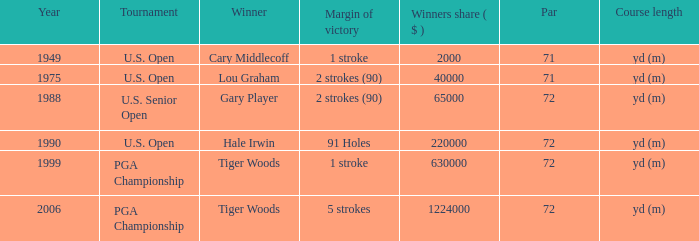When 1999 is the year how many tournaments are there? 1.0. Write the full table. {'header': ['Year', 'Tournament', 'Winner', 'Margin of victory', 'Winners share ( $ )', 'Par', 'Course length'], 'rows': [['1949', 'U.S. Open', 'Cary Middlecoff', '1 stroke', '2000', '71', 'yd (m)'], ['1975', 'U.S. Open', 'Lou Graham', '2 strokes (90)', '40000', '71', 'yd (m)'], ['1988', 'U.S. Senior Open', 'Gary Player', '2 strokes (90)', '65000', '72', 'yd (m)'], ['1990', 'U.S. Open', 'Hale Irwin', '91 Holes', '220000', '72', 'yd (m)'], ['1999', 'PGA Championship', 'Tiger Woods', '1 stroke', '630000', '72', 'yd (m)'], ['2006', 'PGA Championship', 'Tiger Woods', '5 strokes', '1224000', '72', 'yd (m)']]} 